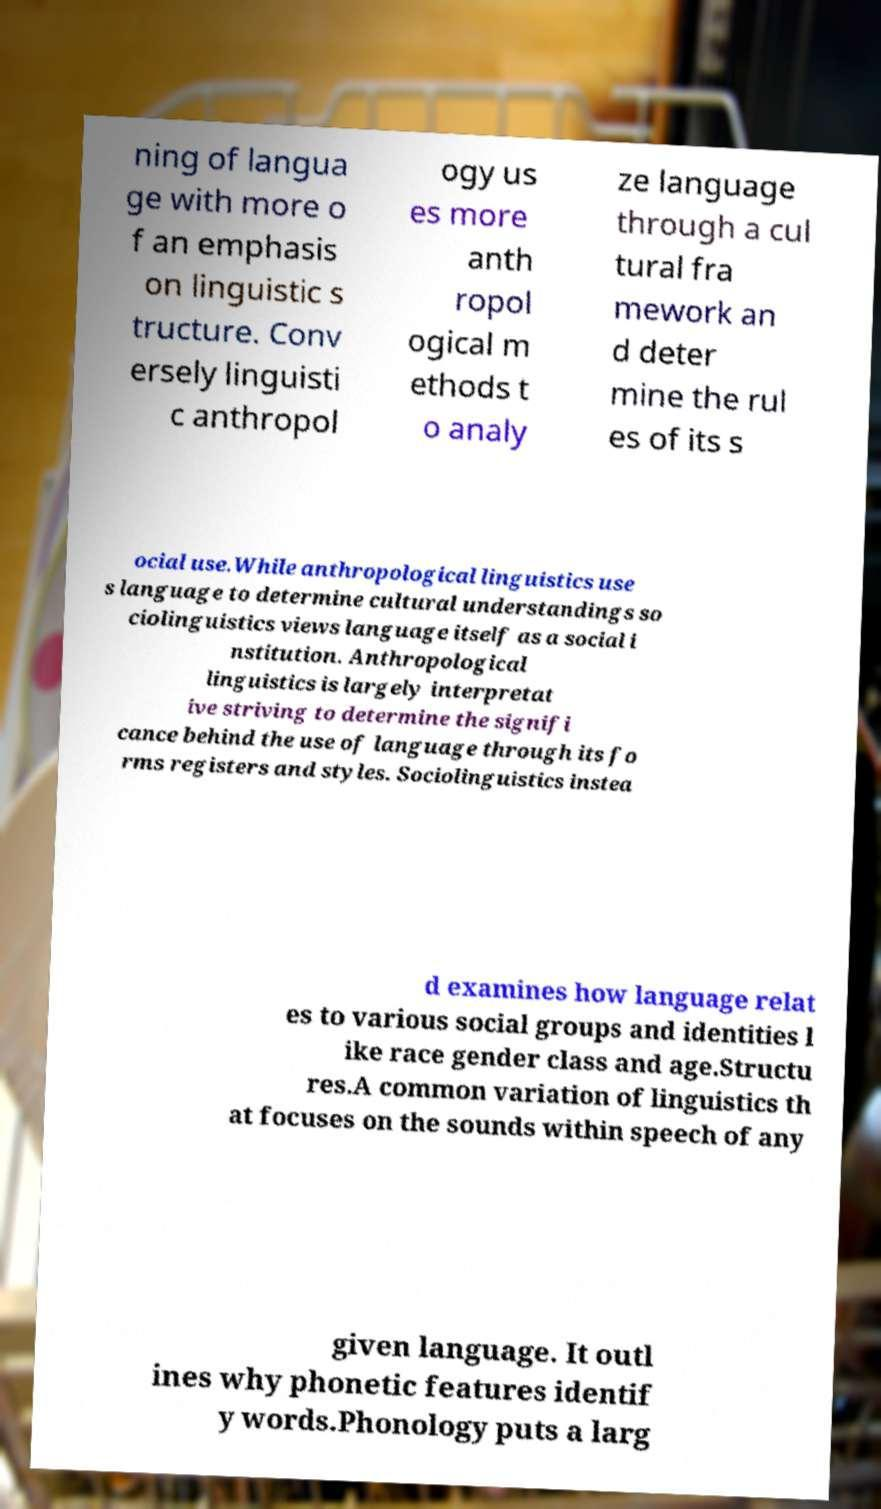Can you read and provide the text displayed in the image?This photo seems to have some interesting text. Can you extract and type it out for me? ning of langua ge with more o f an emphasis on linguistic s tructure. Conv ersely linguisti c anthropol ogy us es more anth ropol ogical m ethods t o analy ze language through a cul tural fra mework an d deter mine the rul es of its s ocial use.While anthropological linguistics use s language to determine cultural understandings so ciolinguistics views language itself as a social i nstitution. Anthropological linguistics is largely interpretat ive striving to determine the signifi cance behind the use of language through its fo rms registers and styles. Sociolinguistics instea d examines how language relat es to various social groups and identities l ike race gender class and age.Structu res.A common variation of linguistics th at focuses on the sounds within speech of any given language. It outl ines why phonetic features identif y words.Phonology puts a larg 